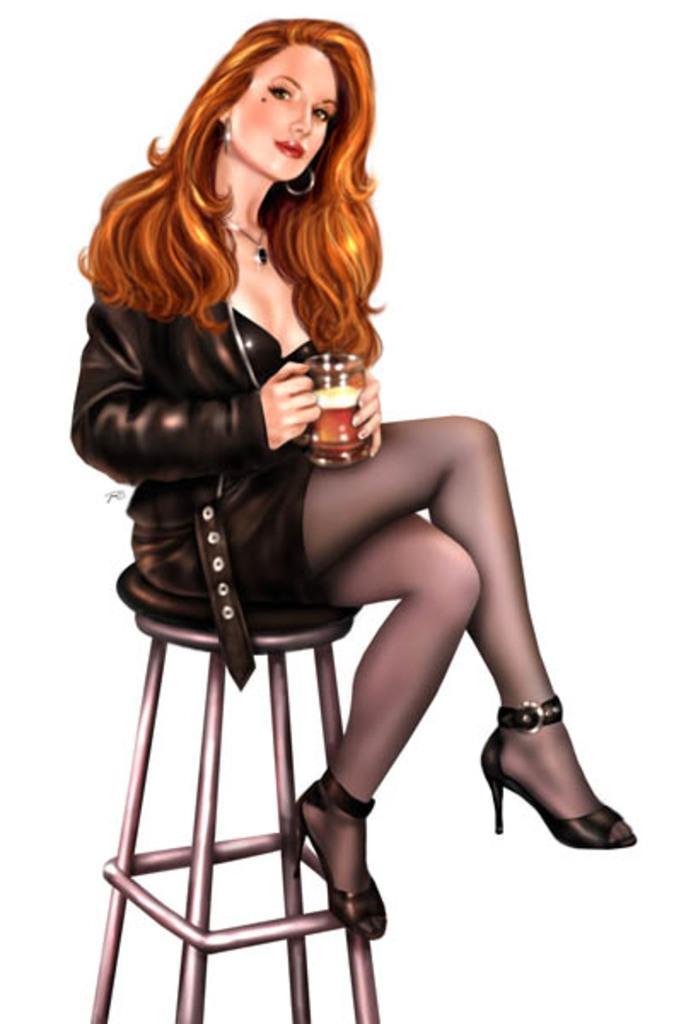Could you give a brief overview of what you see in this image? In this picture we can see a woman sitting on a chair, she is holding a mug. 